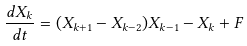Convert formula to latex. <formula><loc_0><loc_0><loc_500><loc_500>\frac { d X _ { k } } { d t } = ( X _ { k + 1 } - X _ { k - 2 } ) X _ { k - 1 } - X _ { k } + F</formula> 